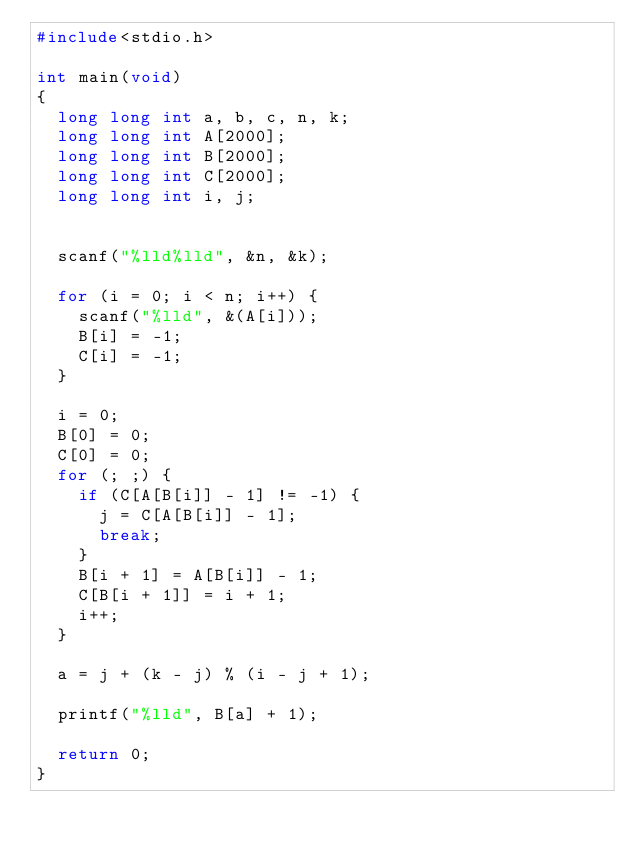Convert code to text. <code><loc_0><loc_0><loc_500><loc_500><_C_>#include<stdio.h>

int main(void)
{
	long long int a, b, c, n, k;
	long long int A[2000];
	long long int B[2000];
	long long int C[2000];
	long long int i, j;


	scanf("%lld%lld", &n, &k);

	for (i = 0; i < n; i++) {
		scanf("%lld", &(A[i]));
		B[i] = -1;
		C[i] = -1;
	}

	i = 0;
	B[0] = 0;
	C[0] = 0;
	for (; ;) {
		if (C[A[B[i]] - 1] != -1) {
			j = C[A[B[i]] - 1];
			break;
		}
		B[i + 1] = A[B[i]] - 1;
		C[B[i + 1]] = i + 1;
		i++;
	}

	a = j + (k - j) % (i - j + 1);

	printf("%lld", B[a] + 1);

	return 0;
}</code> 